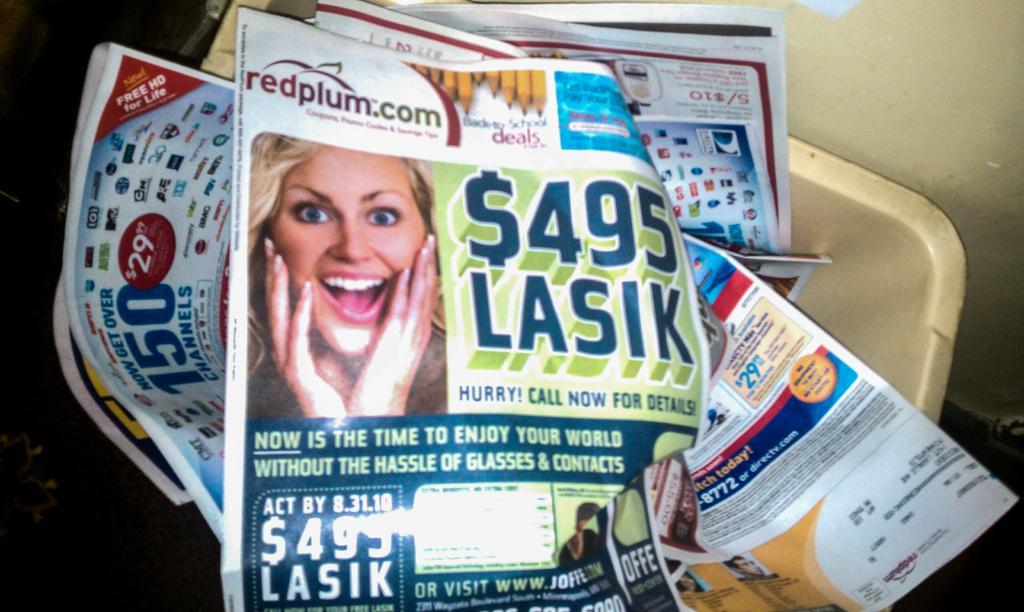How would you summarize this image in a sentence or two? In this image we can see there are posters in the container. 